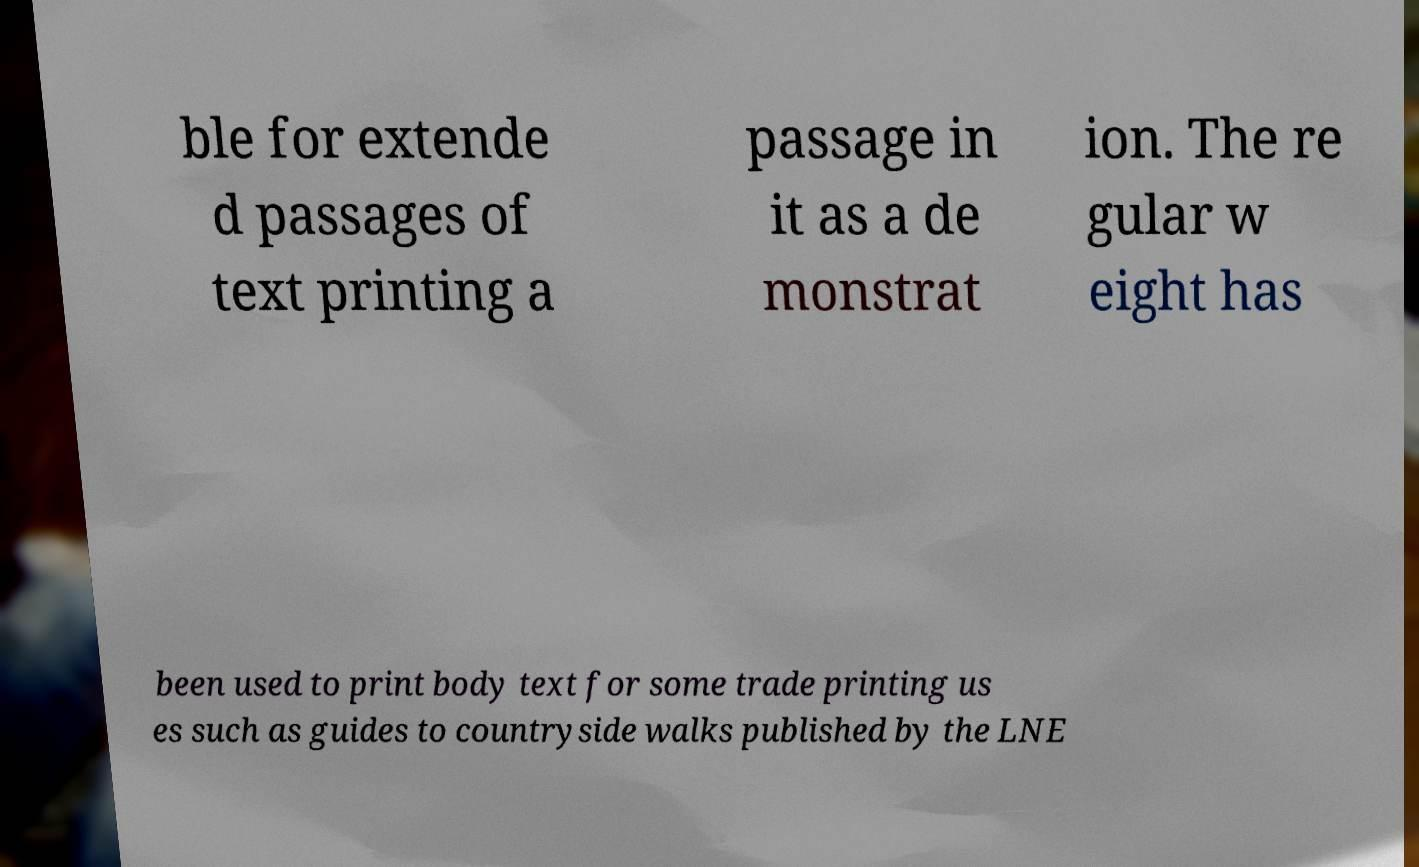Please read and relay the text visible in this image. What does it say? ble for extende d passages of text printing a passage in it as a de monstrat ion. The re gular w eight has been used to print body text for some trade printing us es such as guides to countryside walks published by the LNE 